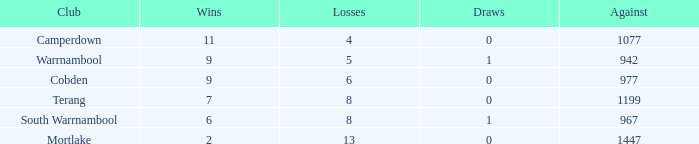How many draws did Mortlake have when the losses were more than 5? 1.0. Would you mind parsing the complete table? {'header': ['Club', 'Wins', 'Losses', 'Draws', 'Against'], 'rows': [['Camperdown', '11', '4', '0', '1077'], ['Warrnambool', '9', '5', '1', '942'], ['Cobden', '9', '6', '0', '977'], ['Terang', '7', '8', '0', '1199'], ['South Warrnambool', '6', '8', '1', '967'], ['Mortlake', '2', '13', '0', '1447']]} 